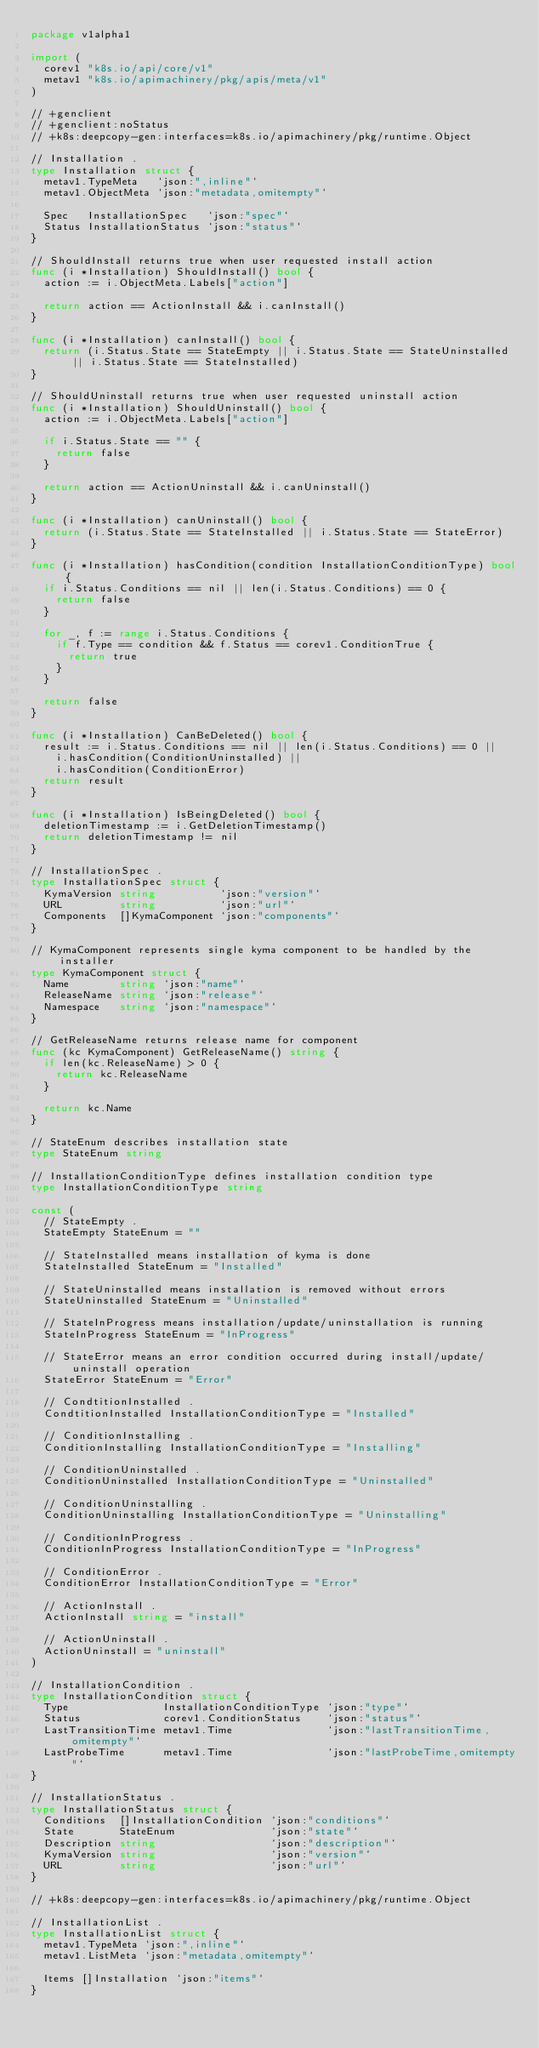<code> <loc_0><loc_0><loc_500><loc_500><_Go_>package v1alpha1

import (
	corev1 "k8s.io/api/core/v1"
	metav1 "k8s.io/apimachinery/pkg/apis/meta/v1"
)

// +genclient
// +genclient:noStatus
// +k8s:deepcopy-gen:interfaces=k8s.io/apimachinery/pkg/runtime.Object

// Installation .
type Installation struct {
	metav1.TypeMeta   `json:",inline"`
	metav1.ObjectMeta `json:"metadata,omitempty"`

	Spec   InstallationSpec   `json:"spec"`
	Status InstallationStatus `json:"status"`
}

// ShouldInstall returns true when user requested install action
func (i *Installation) ShouldInstall() bool {
	action := i.ObjectMeta.Labels["action"]

	return action == ActionInstall && i.canInstall()
}

func (i *Installation) canInstall() bool {
	return (i.Status.State == StateEmpty || i.Status.State == StateUninstalled || i.Status.State == StateInstalled)
}

// ShouldUninstall returns true when user requested uninstall action
func (i *Installation) ShouldUninstall() bool {
	action := i.ObjectMeta.Labels["action"]

	if i.Status.State == "" {
		return false
	}

	return action == ActionUninstall && i.canUninstall()
}

func (i *Installation) canUninstall() bool {
	return (i.Status.State == StateInstalled || i.Status.State == StateError)
}

func (i *Installation) hasCondition(condition InstallationConditionType) bool {
	if i.Status.Conditions == nil || len(i.Status.Conditions) == 0 {
		return false
	}

	for _, f := range i.Status.Conditions {
		if f.Type == condition && f.Status == corev1.ConditionTrue {
			return true
		}
	}

	return false
}

func (i *Installation) CanBeDeleted() bool {
	result := i.Status.Conditions == nil || len(i.Status.Conditions) == 0 ||
		i.hasCondition(ConditionUninstalled) ||
		i.hasCondition(ConditionError)
	return result
}

func (i *Installation) IsBeingDeleted() bool {
	deletionTimestamp := i.GetDeletionTimestamp()
	return deletionTimestamp != nil
}

// InstallationSpec .
type InstallationSpec struct {
	KymaVersion string          `json:"version"`
	URL         string          `json:"url"`
	Components  []KymaComponent `json:"components"`
}

// KymaComponent represents single kyma component to be handled by the installer
type KymaComponent struct {
	Name        string `json:"name"`
	ReleaseName string `json:"release"`
	Namespace   string `json:"namespace"`
}

// GetReleaseName returns release name for component
func (kc KymaComponent) GetReleaseName() string {
	if len(kc.ReleaseName) > 0 {
		return kc.ReleaseName
	}

	return kc.Name
}

// StateEnum describes installation state
type StateEnum string

// InstallationConditionType defines installation condition type
type InstallationConditionType string

const (
	// StateEmpty .
	StateEmpty StateEnum = ""

	// StateInstalled means installation of kyma is done
	StateInstalled StateEnum = "Installed"

	// StateUninstalled means installation is removed without errors
	StateUninstalled StateEnum = "Uninstalled"

	// StateInProgress means installation/update/uninstallation is running
	StateInProgress StateEnum = "InProgress"

	// StateError means an error condition occurred during install/update/uninstall operation
	StateError StateEnum = "Error"

	// CondtitionInstalled .
	CondtitionInstalled InstallationConditionType = "Installed"

	// ConditionInstalling .
	ConditionInstalling InstallationConditionType = "Installing"

	// ConditionUninstalled .
	ConditionUninstalled InstallationConditionType = "Uninstalled"

	// ConditionUninstalling .
	ConditionUninstalling InstallationConditionType = "Uninstalling"

	// ConditionInProgress .
	ConditionInProgress InstallationConditionType = "InProgress"

	// ConditionError .
	ConditionError InstallationConditionType = "Error"

	// ActionInstall .
	ActionInstall string = "install"

	// ActionUninstall .
	ActionUninstall = "uninstall"
)

// InstallationCondition .
type InstallationCondition struct {
	Type               InstallationConditionType `json:"type"`
	Status             corev1.ConditionStatus    `json:"status"`
	LastTransitionTime metav1.Time               `json:"lastTransitionTime,omitempty"`
	LastProbeTime      metav1.Time               `json:"lastProbeTime,omitempty"`
}

// InstallationStatus .
type InstallationStatus struct {
	Conditions  []InstallationCondition `json:"conditions"`
	State       StateEnum               `json:"state"`
	Description string                  `json:"description"`
	KymaVersion string                  `json:"version"`
	URL         string                  `json:"url"`
}

// +k8s:deepcopy-gen:interfaces=k8s.io/apimachinery/pkg/runtime.Object

// InstallationList .
type InstallationList struct {
	metav1.TypeMeta `json:",inline"`
	metav1.ListMeta `json:"metadata,omitempty"`

	Items []Installation `json:"items"`
}
</code> 